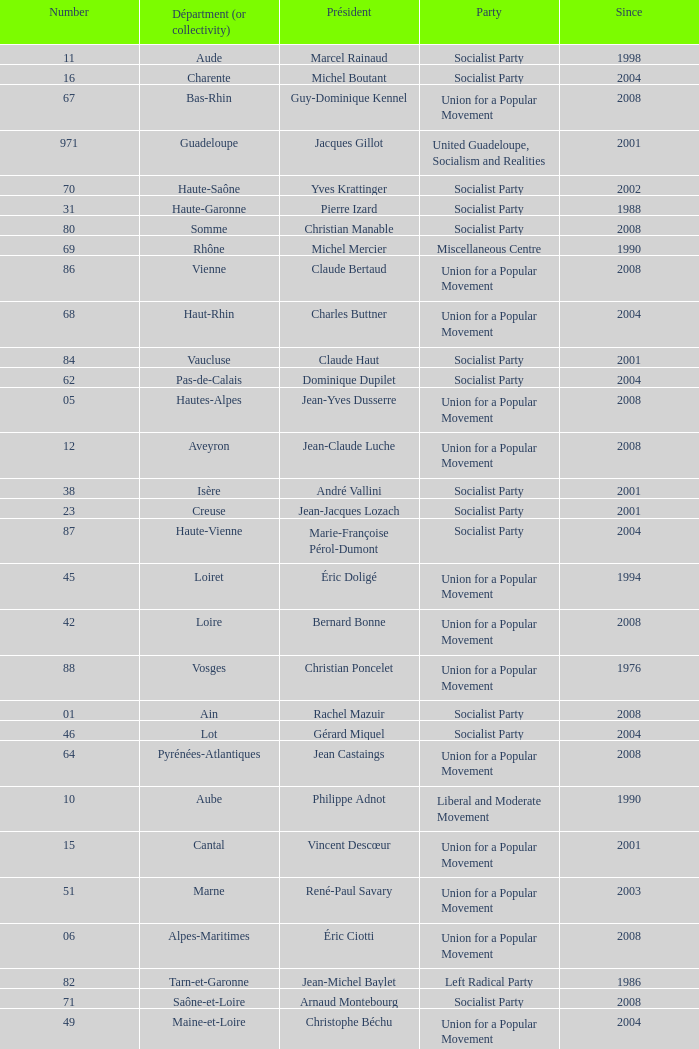Who is the president representing the Creuse department? Jean-Jacques Lozach. 